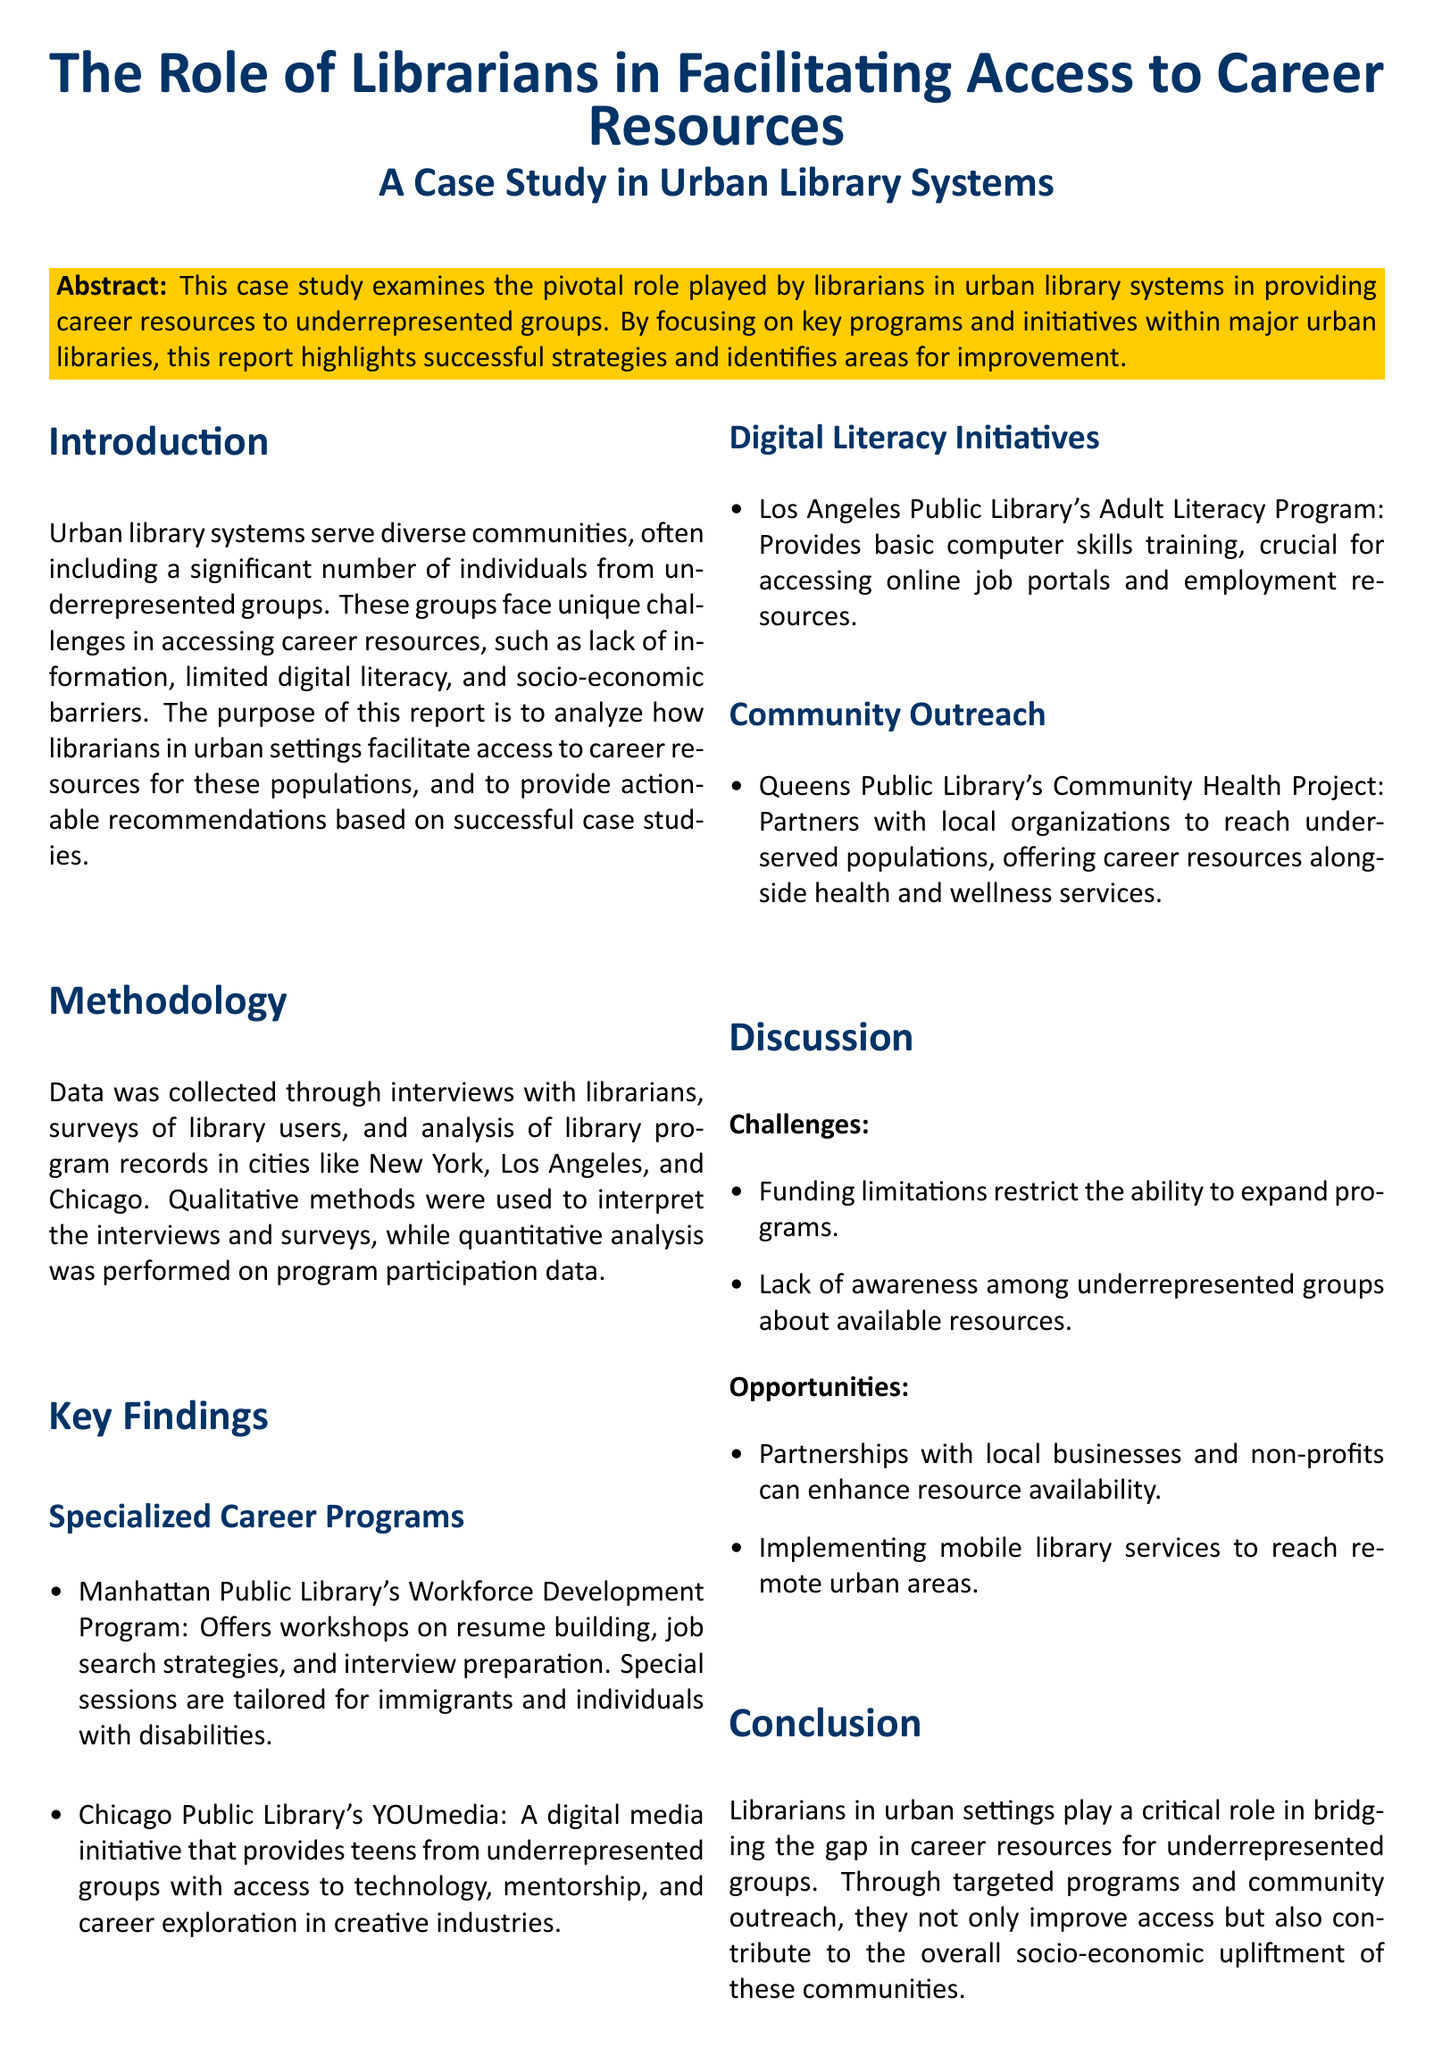What is the main subject of the case study? The main subject is the role of librarians in providing career resources to underrepresented groups in urban library systems.
Answer: The role of librarians in providing career resources What cities were involved in the study? The study focused on urban library systems in multiple cities, specifically named in the document.
Answer: New York, Los Angeles, and Chicago What program offers workshops tailored for immigrants? This program is specifically aimed at providing career resources for immigrants, as stated in the findings section.
Answer: Manhattan Public Library's Workforce Development Program What type of training is provided by the Adult Literacy Program? The Adult Literacy Program focuses on equipping users with essential skills needed to navigate online resources.
Answer: Basic computer skills training What is a challenge mentioned in the discussion? The discussion highlights specific obstacles faced by libraries in providing adequate resources to underrepresented groups.
Answer: Funding limitations What is one opportunity identified for enhancing resource availability? This refers to the potential for collaboration with other organizations to improve access to career resources.
Answer: Partnerships with local businesses and non-profits What type of initiative does the YOUmedia project represent? This indicates the specific kind of program that supports teens from underrepresented groups in creative career exploration.
Answer: A digital media initiative What is the overall conclusion about librarians in urban settings? This statement summarizes the key role that librarians play in improving access to career resources.
Answer: They play a critical role in bridging the gap in career resources 